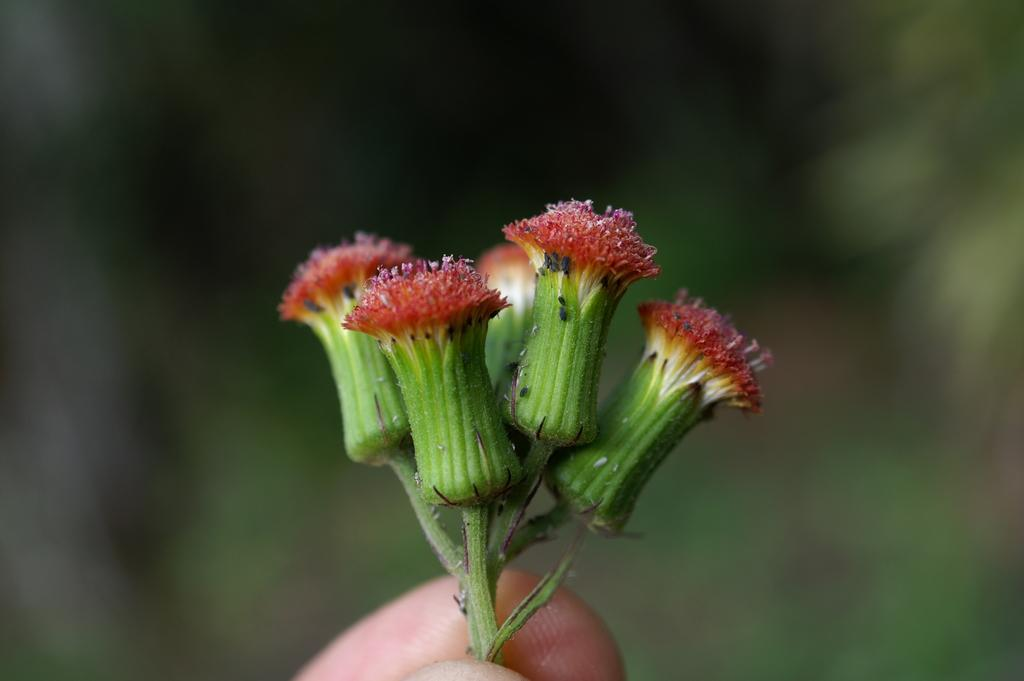What can be observed about the background of the image? The background of the image is blurred. What type of plant life is present in the image? There are flower buds in the image. What body part is visible at the bottom portion of the image? Fingers are visible at the bottom portion of the image. What type of fruit is being painted by the toad in the image? There is no fruit or toad present in the image. 